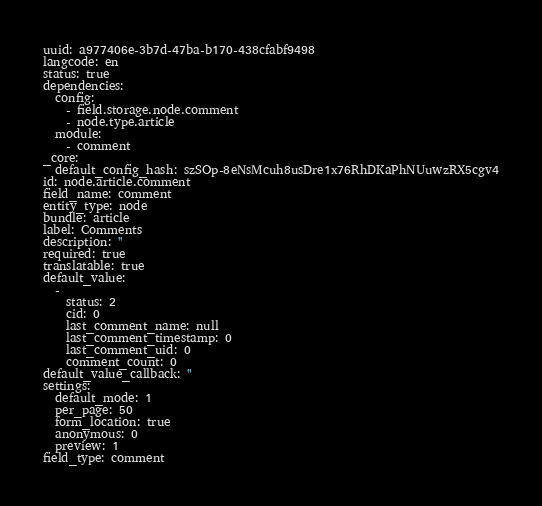Convert code to text. <code><loc_0><loc_0><loc_500><loc_500><_YAML_>uuid: a977406e-3b7d-47ba-b170-438cfabf9498
langcode: en
status: true
dependencies:
  config:
    - field.storage.node.comment
    - node.type.article
  module:
    - comment
_core:
  default_config_hash: szSOp-8eNsMcuh8usDre1x76RhDKaPhNUuwzRX5cgv4
id: node.article.comment
field_name: comment
entity_type: node
bundle: article
label: Comments
description: ''
required: true
translatable: true
default_value:
  -
    status: 2
    cid: 0
    last_comment_name: null
    last_comment_timestamp: 0
    last_comment_uid: 0
    comment_count: 0
default_value_callback: ''
settings:
  default_mode: 1
  per_page: 50
  form_location: true
  anonymous: 0
  preview: 1
field_type: comment
</code> 